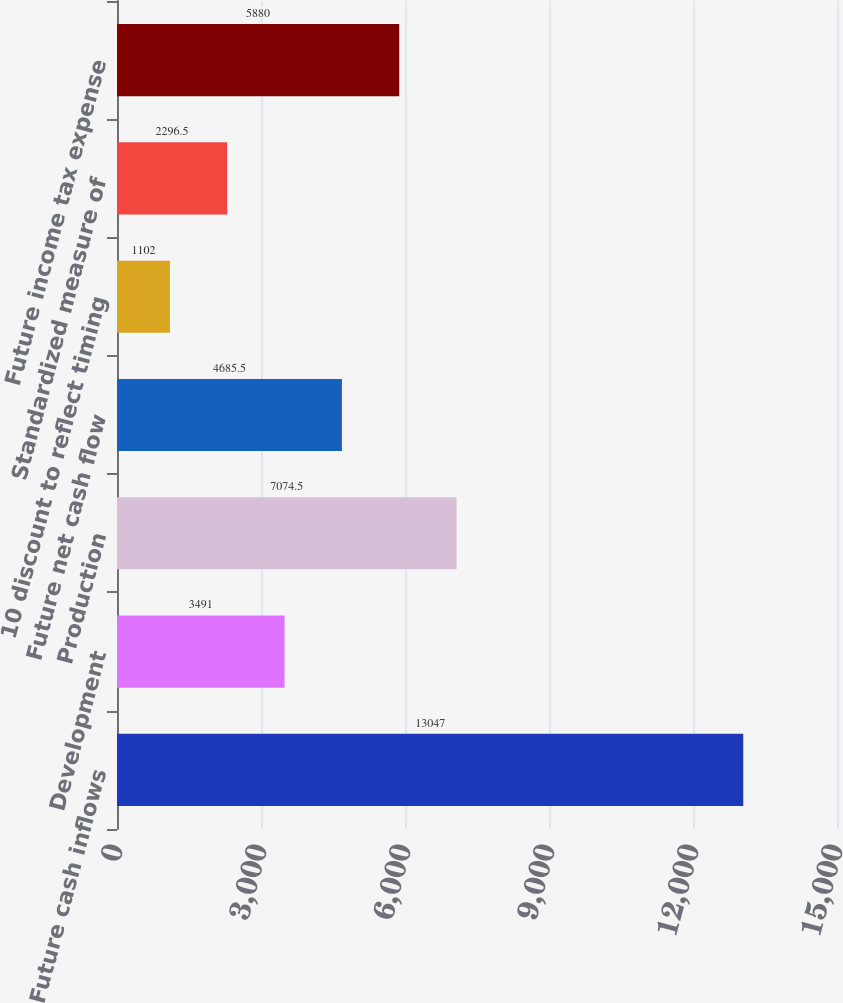Convert chart to OTSL. <chart><loc_0><loc_0><loc_500><loc_500><bar_chart><fcel>Future cash inflows<fcel>Development<fcel>Production<fcel>Future net cash flow<fcel>10 discount to reflect timing<fcel>Standardized measure of<fcel>Future income tax expense<nl><fcel>13047<fcel>3491<fcel>7074.5<fcel>4685.5<fcel>1102<fcel>2296.5<fcel>5880<nl></chart> 